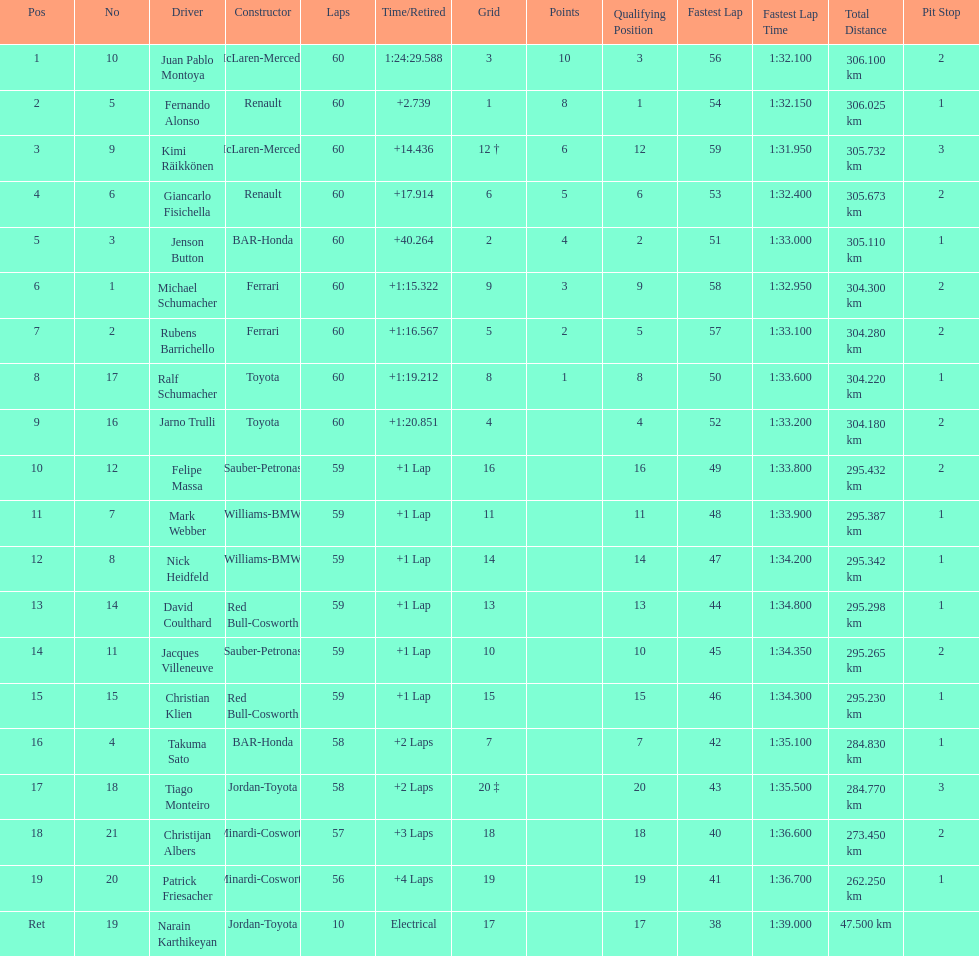How many drivers received points from the race? 8. 